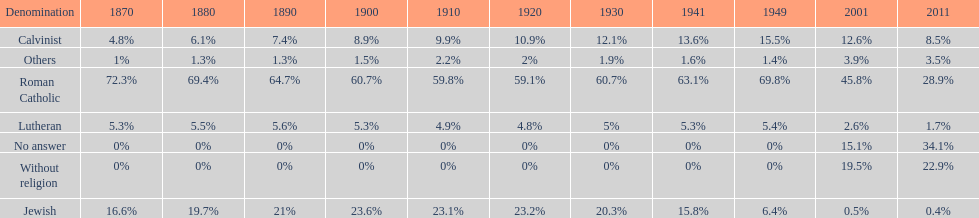Which denomination has the highest margin? Roman Catholic. 